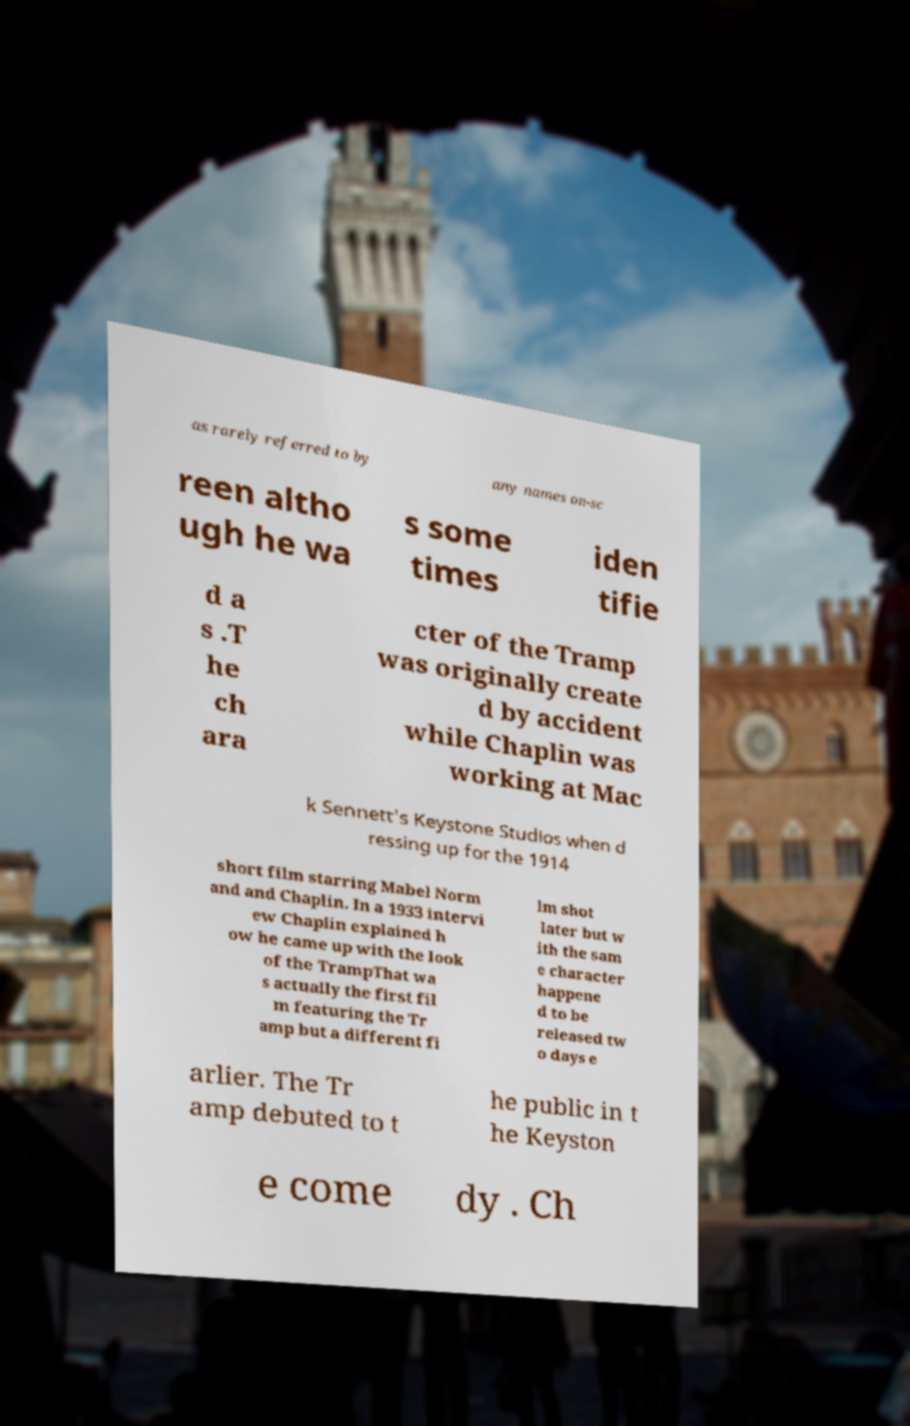What messages or text are displayed in this image? I need them in a readable, typed format. as rarely referred to by any names on-sc reen altho ugh he wa s some times iden tifie d a s .T he ch ara cter of the Tramp was originally create d by accident while Chaplin was working at Mac k Sennett's Keystone Studios when d ressing up for the 1914 short film starring Mabel Norm and and Chaplin. In a 1933 intervi ew Chaplin explained h ow he came up with the look of the TrampThat wa s actually the first fil m featuring the Tr amp but a different fi lm shot later but w ith the sam e character happene d to be released tw o days e arlier. The Tr amp debuted to t he public in t he Keyston e come dy . Ch 